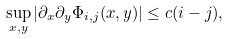Convert formula to latex. <formula><loc_0><loc_0><loc_500><loc_500>\sup _ { x , y } | \partial _ { x } \partial _ { y } \Phi _ { i , j } ( x , y ) | \leq c ( i - j ) ,</formula> 